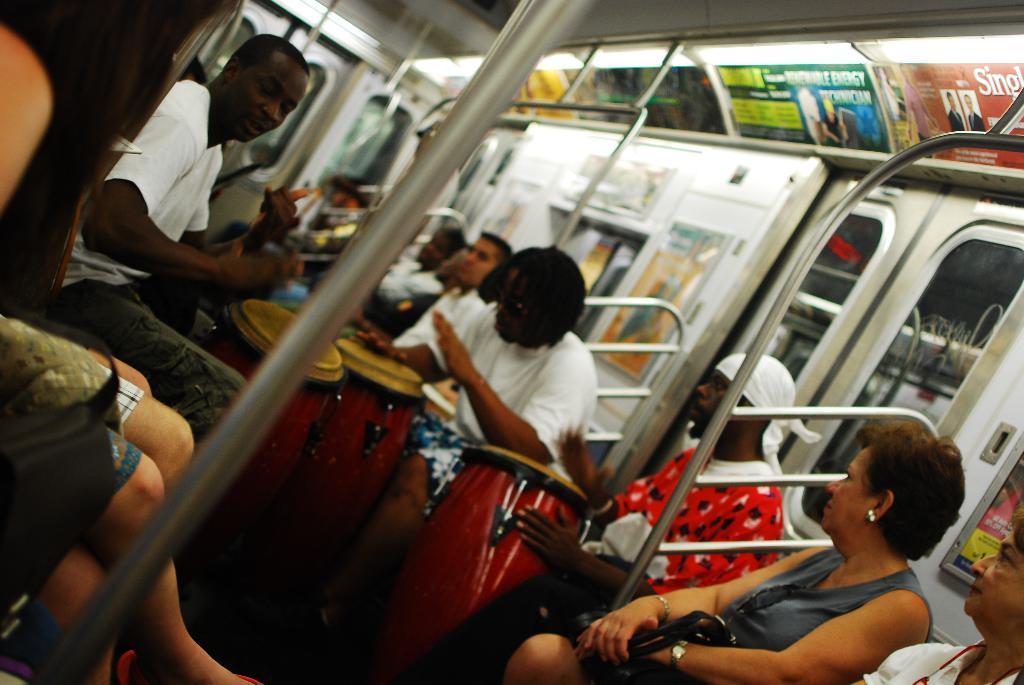Describe this image in one or two sentences. In this image I can see group of people sitting. In front the person is sitting and playing few musical instruments and the person is wearing white color shirt and I can see the inner part of the vehicle and I can also see few rods and windows. 